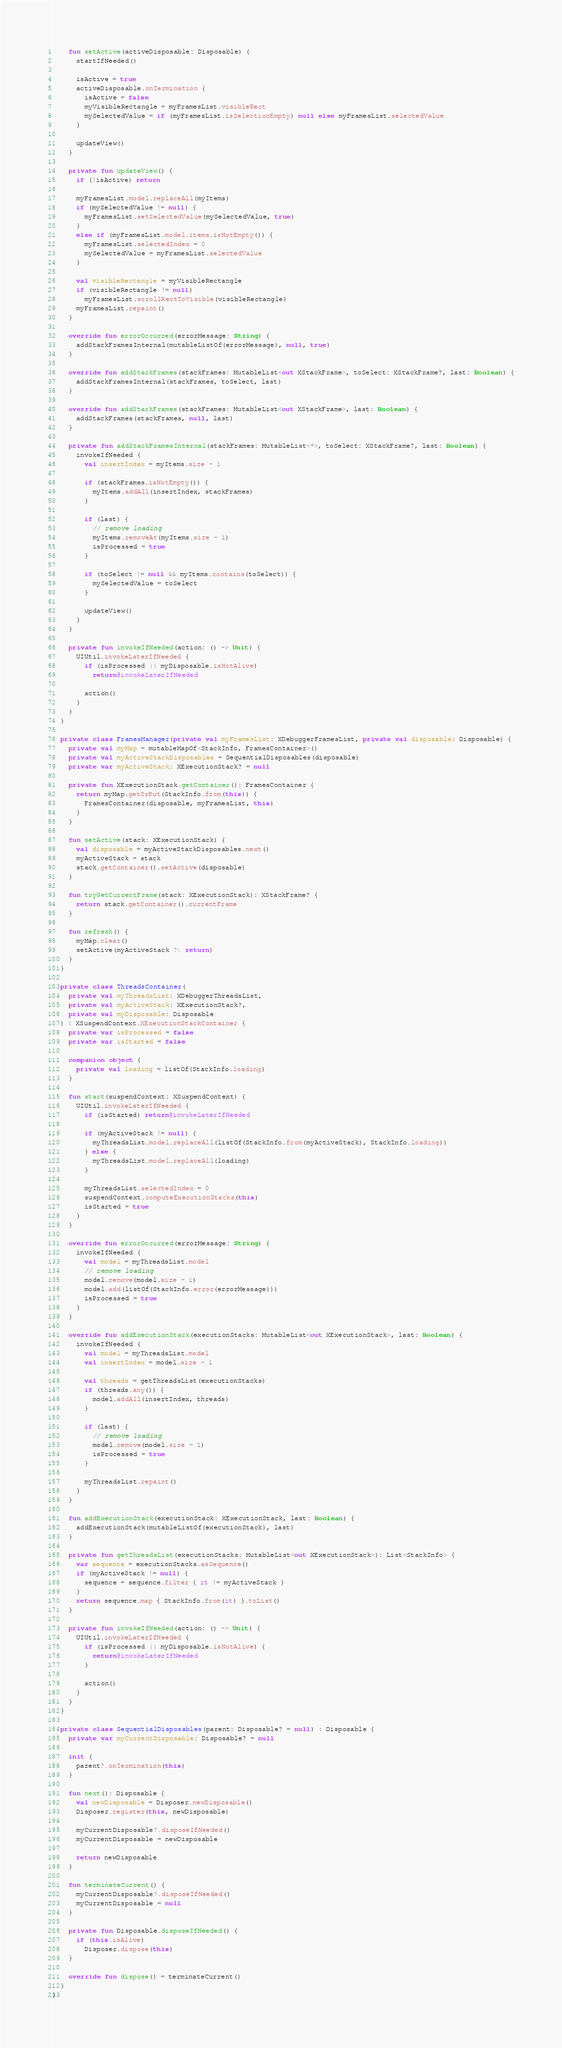<code> <loc_0><loc_0><loc_500><loc_500><_Kotlin_>
    fun setActive(activeDisposable: Disposable) {
      startIfNeeded()

      isActive = true
      activeDisposable.onTermination {
        isActive = false
        myVisibleRectangle = myFramesList.visibleRect
        mySelectedValue = if (myFramesList.isSelectionEmpty) null else myFramesList.selectedValue
      }

      updateView()
    }

    private fun updateView() {
      if (!isActive) return

      myFramesList.model.replaceAll(myItems)
      if (mySelectedValue != null) {
        myFramesList.setSelectedValue(mySelectedValue, true)
      }
      else if (myFramesList.model.items.isNotEmpty()) {
        myFramesList.selectedIndex = 0
        mySelectedValue = myFramesList.selectedValue
      }

      val visibleRectangle = myVisibleRectangle
      if (visibleRectangle != null)
        myFramesList.scrollRectToVisible(visibleRectangle)
      myFramesList.repaint()
    }

    override fun errorOccurred(errorMessage: String) {
      addStackFramesInternal(mutableListOf(errorMessage), null, true)
    }

    override fun addStackFrames(stackFrames: MutableList<out XStackFrame>, toSelect: XStackFrame?, last: Boolean) {
      addStackFramesInternal(stackFrames, toSelect, last)
    }

    override fun addStackFrames(stackFrames: MutableList<out XStackFrame>, last: Boolean) {
      addStackFrames(stackFrames, null, last)
    }

    private fun addStackFramesInternal(stackFrames: MutableList<*>, toSelect: XStackFrame?, last: Boolean) {
      invokeIfNeeded {
        val insertIndex = myItems.size - 1

        if (stackFrames.isNotEmpty()) {
          myItems.addAll(insertIndex, stackFrames)
        }

        if (last) {
          // remove loading
          myItems.removeAt(myItems.size - 1)
          isProcessed = true
        }

        if (toSelect != null && myItems.contains(toSelect)) {
          mySelectedValue = toSelect
        }

        updateView()
      }
    }

    private fun invokeIfNeeded(action: () -> Unit) {
      UIUtil.invokeLaterIfNeeded {
        if (isProcessed || myDisposable.isNotAlive)
          return@invokeLaterIfNeeded

        action()
      }
    }
  }

  private class FramesManager(private val myFramesList: XDebuggerFramesList, private val disposable: Disposable) {
    private val myMap = mutableMapOf<StackInfo, FramesContainer>()
    private val myActiveStackDisposables = SequentialDisposables(disposable)
    private var myActiveStack: XExecutionStack? = null

    private fun XExecutionStack.getContainer(): FramesContainer {
      return myMap.getOrPut(StackInfo.from(this)) {
        FramesContainer(disposable, myFramesList, this)
      }
    }

    fun setActive(stack: XExecutionStack) {
      val disposable = myActiveStackDisposables.next()
      myActiveStack = stack
      stack.getContainer().setActive(disposable)
    }

    fun tryGetCurrentFrame(stack: XExecutionStack): XStackFrame? {
      return stack.getContainer().currentFrame
    }

    fun refresh() {
      myMap.clear()
      setActive(myActiveStack ?: return)
    }
  }

  private class ThreadsContainer(
    private val myThreadsList: XDebuggerThreadsList,
    private val myActiveStack: XExecutionStack?,
    private val myDisposable: Disposable
  ) : XSuspendContext.XExecutionStackContainer {
    private var isProcessed = false
    private var isStarted = false

    companion object {
      private val loading = listOf(StackInfo.loading)
    }

    fun start(suspendContext: XSuspendContext) {
      UIUtil.invokeLaterIfNeeded {
        if (isStarted) return@invokeLaterIfNeeded

        if (myActiveStack != null) {
          myThreadsList.model.replaceAll(listOf(StackInfo.from(myActiveStack), StackInfo.loading))
        } else {
          myThreadsList.model.replaceAll(loading)
        }

        myThreadsList.selectedIndex = 0
        suspendContext.computeExecutionStacks(this)
        isStarted = true
      }
    }

    override fun errorOccurred(errorMessage: String) {
      invokeIfNeeded {
        val model = myThreadsList.model
        // remove loading
        model.remove(model.size - 1)
        model.add(listOf(StackInfo.error(errorMessage)))
        isProcessed = true
      }
    }

    override fun addExecutionStack(executionStacks: MutableList<out XExecutionStack>, last: Boolean) {
      invokeIfNeeded {
        val model = myThreadsList.model
        val insertIndex = model.size - 1

        val threads = getThreadsList(executionStacks)
        if (threads.any()) {
          model.addAll(insertIndex, threads)
        }

        if (last) {
          // remove loading
          model.remove(model.size - 1)
          isProcessed = true
        }

        myThreadsList.repaint()
      }
    }

    fun addExecutionStack(executionStack: XExecutionStack, last: Boolean) {
      addExecutionStack(mutableListOf(executionStack), last)
    }

    private fun getThreadsList(executionStacks: MutableList<out XExecutionStack>): List<StackInfo> {
      var sequence = executionStacks.asSequence()
      if (myActiveStack != null) {
        sequence = sequence.filter { it != myActiveStack }
      }
      return sequence.map { StackInfo.from(it) }.toList()
    }

    private fun invokeIfNeeded(action: () -> Unit) {
      UIUtil.invokeLaterIfNeeded {
        if (isProcessed || myDisposable.isNotAlive) {
          return@invokeLaterIfNeeded
        }

        action()
      }
    }
  }

  private class SequentialDisposables(parent: Disposable? = null) : Disposable {
    private var myCurrentDisposable: Disposable? = null

    init {
      parent?.onTermination(this)
    }

    fun next(): Disposable {
      val newDisposable = Disposer.newDisposable()
      Disposer.register(this, newDisposable)

      myCurrentDisposable?.disposeIfNeeded()
      myCurrentDisposable = newDisposable

      return newDisposable
    }

    fun terminateCurrent() {
      myCurrentDisposable?.disposeIfNeeded()
      myCurrentDisposable = null
    }

    private fun Disposable.disposeIfNeeded() {
      if (this.isAlive)
        Disposer.dispose(this)
    }

    override fun dispose() = terminateCurrent()
  }
}
</code> 